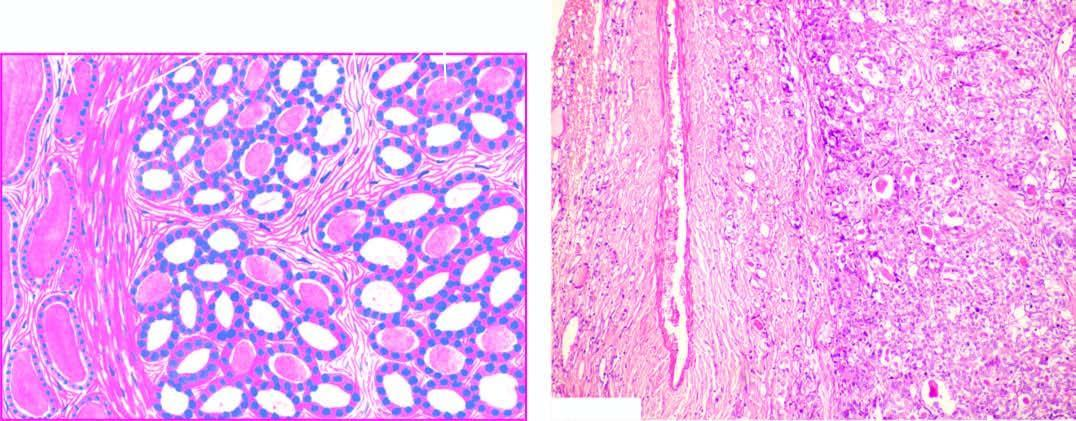does taghorn renal stone with chronic pyelonephritisthe kidney consist of small follicles lined by cuboidal epithelium and contain little or no colloid and separated by abundant loose stroma?
Answer the question using a single word or phrase. No 